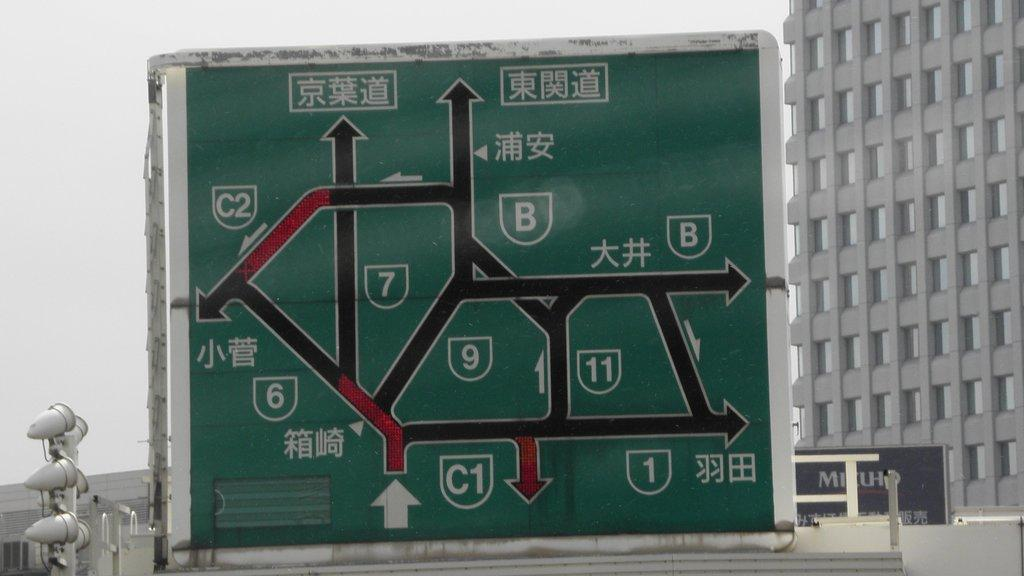<image>
Relay a brief, clear account of the picture shown. The green sign is giving directions to get to different roads, like the C2. 